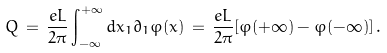Convert formula to latex. <formula><loc_0><loc_0><loc_500><loc_500>Q \, = \, \frac { e L } { 2 \pi } \int _ { - \infty } ^ { + \infty } d x _ { 1 } \partial _ { 1 } \varphi ( x ) \, = \, \frac { e L } { 2 \pi } [ \varphi ( + \infty ) - \varphi ( - \infty ) ] \, .</formula> 